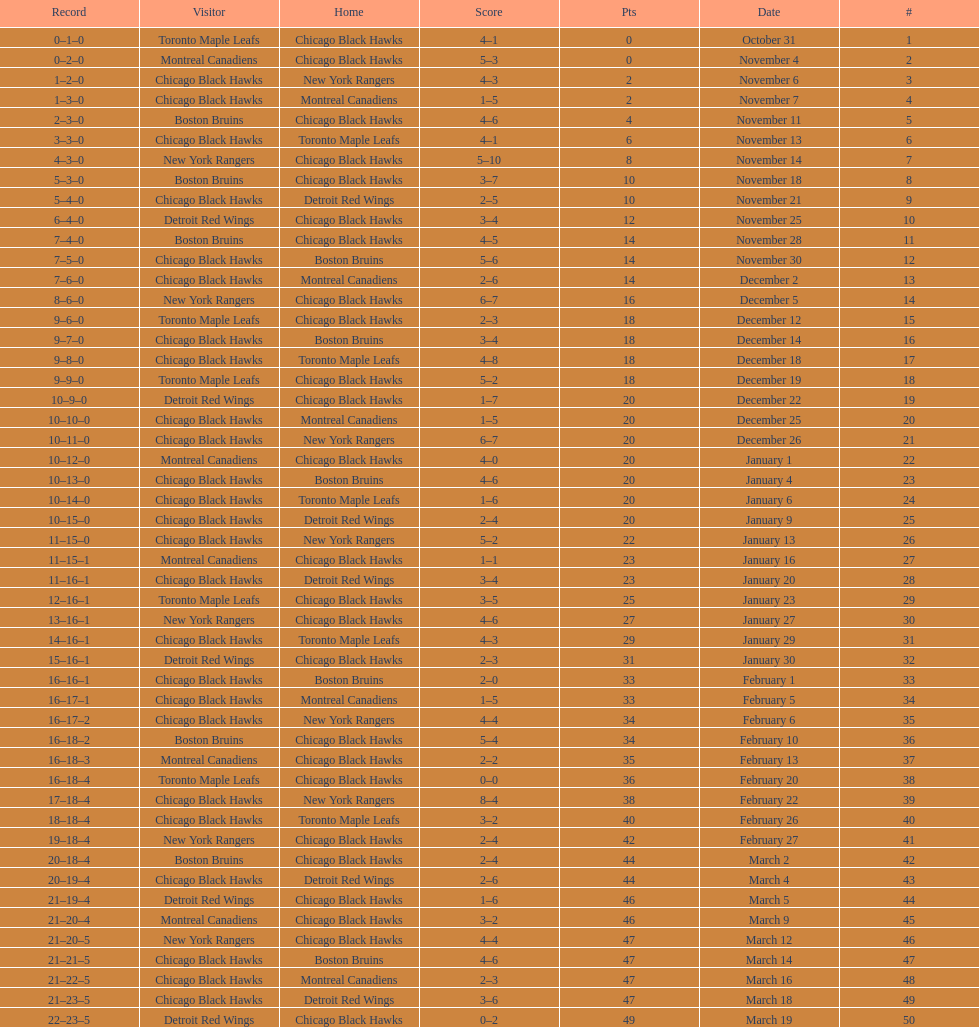What is was the difference in score in the december 19th win? 3. 